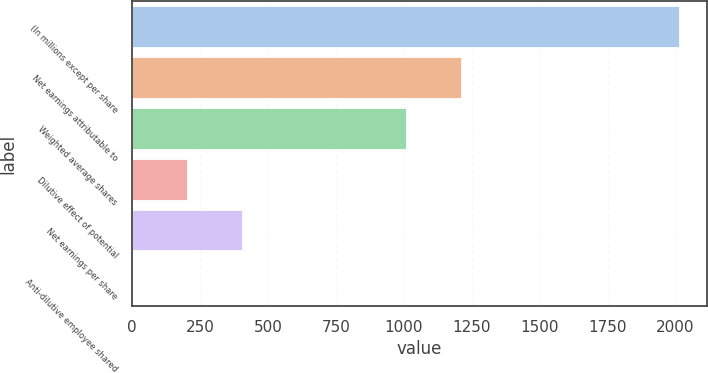Convert chart to OTSL. <chart><loc_0><loc_0><loc_500><loc_500><bar_chart><fcel>(In millions except per share<fcel>Net earnings attributable to<fcel>Weighted average shares<fcel>Dilutive effect of potential<fcel>Net earnings per share<fcel>Anti-dilutive employee shared<nl><fcel>2014<fcel>1208.64<fcel>1007.3<fcel>201.94<fcel>403.28<fcel>0.6<nl></chart> 